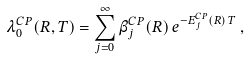<formula> <loc_0><loc_0><loc_500><loc_500>\lambda ^ { C P } _ { 0 } ( R , T ) = \sum _ { j = 0 } ^ { \infty } \beta ^ { C P } _ { j } ( R ) \, e ^ { - E ^ { C P } _ { j } ( R ) \, T } \, ,</formula> 